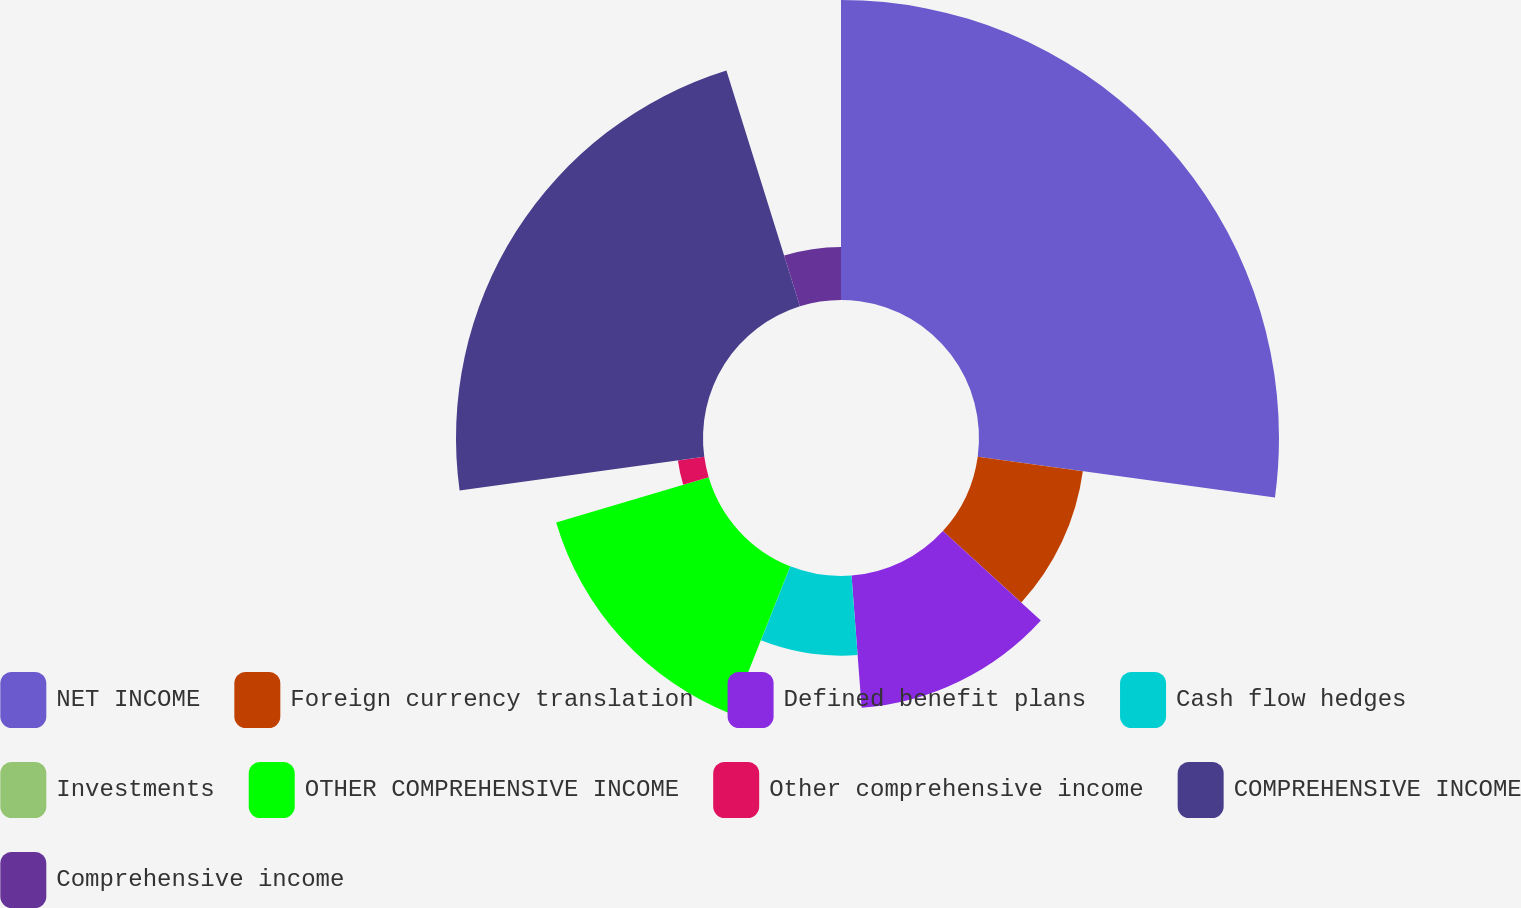Convert chart. <chart><loc_0><loc_0><loc_500><loc_500><pie_chart><fcel>NET INCOME<fcel>Foreign currency translation<fcel>Defined benefit plans<fcel>Cash flow hedges<fcel>Investments<fcel>OTHER COMPREHENSIVE INCOME<fcel>Other comprehensive income<fcel>COMPREHENSIVE INCOME<fcel>Comprehensive income<nl><fcel>27.17%<fcel>9.61%<fcel>12.01%<fcel>7.21%<fcel>0.01%<fcel>14.41%<fcel>2.41%<fcel>22.37%<fcel>4.81%<nl></chart> 